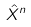Convert formula to latex. <formula><loc_0><loc_0><loc_500><loc_500>\hat { X } ^ { n }</formula> 